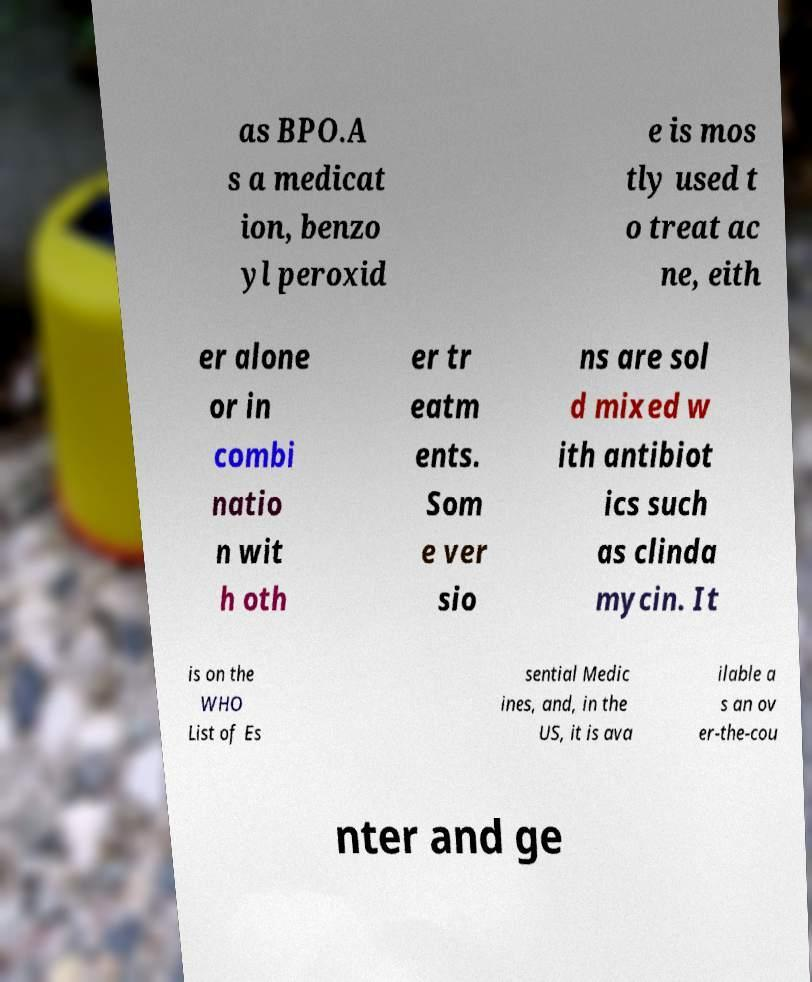I need the written content from this picture converted into text. Can you do that? as BPO.A s a medicat ion, benzo yl peroxid e is mos tly used t o treat ac ne, eith er alone or in combi natio n wit h oth er tr eatm ents. Som e ver sio ns are sol d mixed w ith antibiot ics such as clinda mycin. It is on the WHO List of Es sential Medic ines, and, in the US, it is ava ilable a s an ov er-the-cou nter and ge 